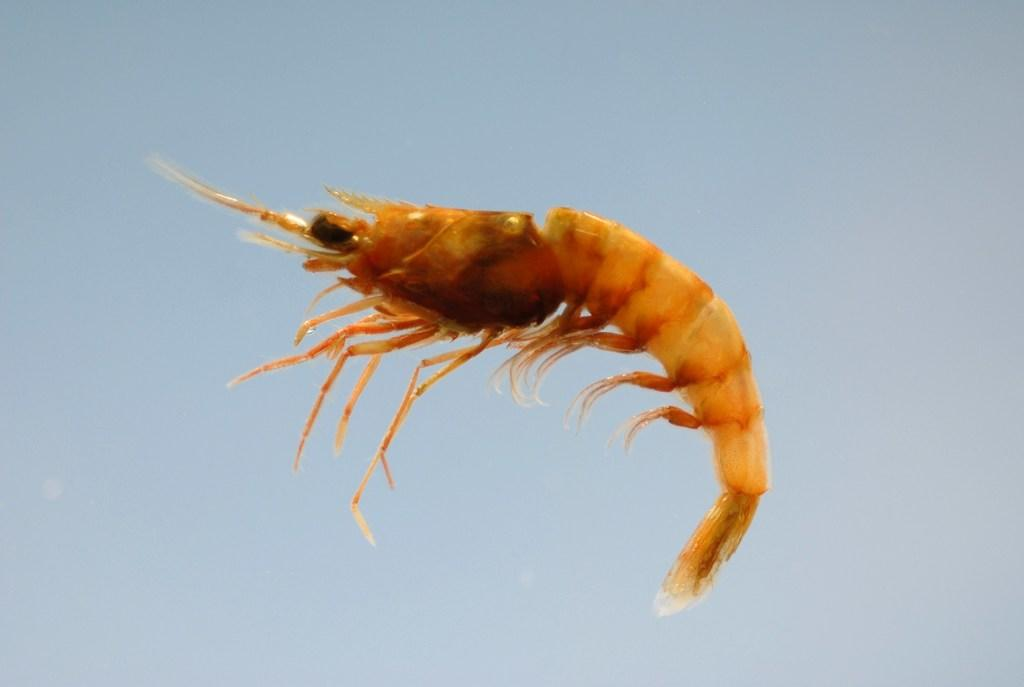What type of animal can be seen in the image? There is an aquatic animal in the image. What color is the background of the image? The background of the image is light blue in color. What is your opinion on the hall at night in the image? There is no mention of a hall or nighttime in the image, as it features an aquatic animal with a light blue background. 